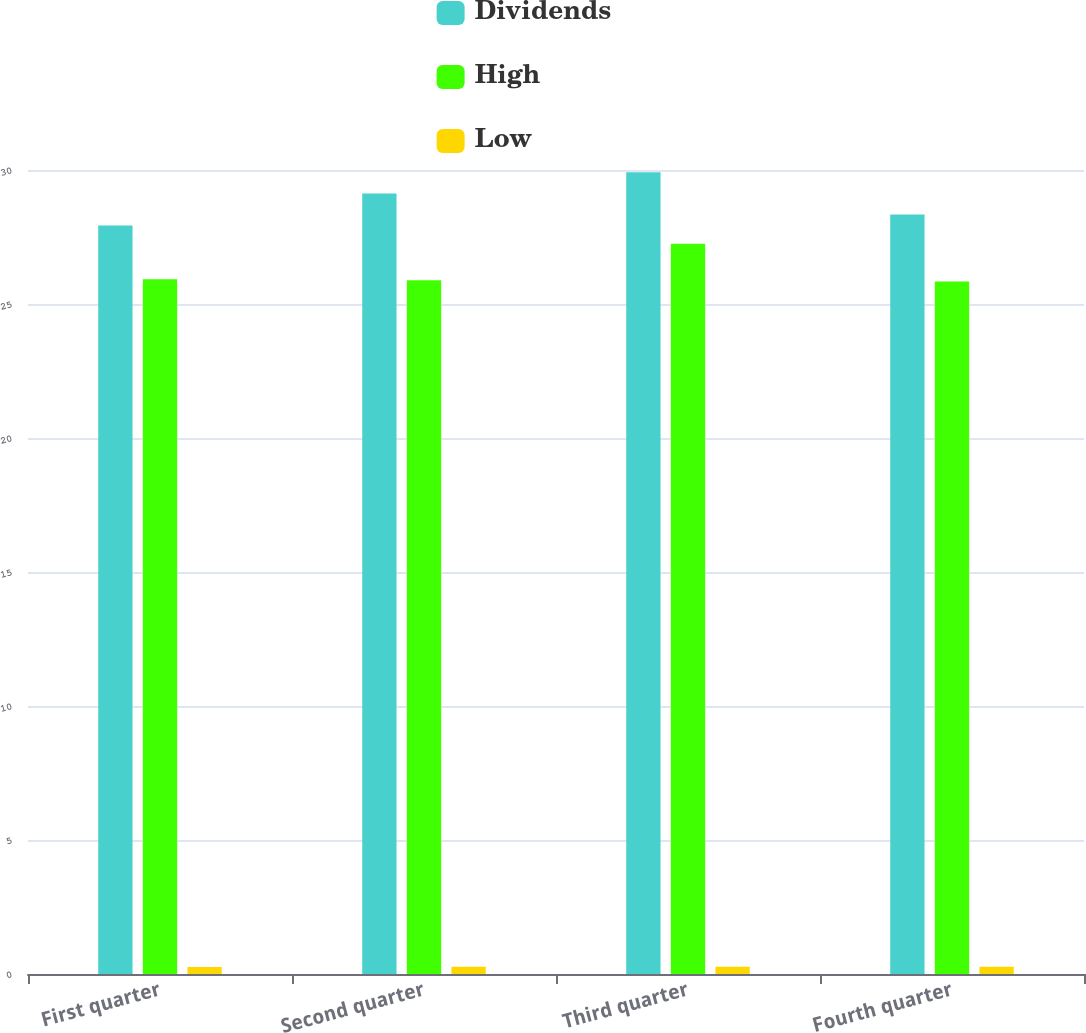<chart> <loc_0><loc_0><loc_500><loc_500><stacked_bar_chart><ecel><fcel>First quarter<fcel>Second quarter<fcel>Third quarter<fcel>Fourth quarter<nl><fcel>Dividends<fcel>27.93<fcel>29.12<fcel>29.92<fcel>28.34<nl><fcel>High<fcel>25.92<fcel>25.89<fcel>27.25<fcel>25.84<nl><fcel>Low<fcel>0.26<fcel>0.27<fcel>0.27<fcel>0.27<nl></chart> 